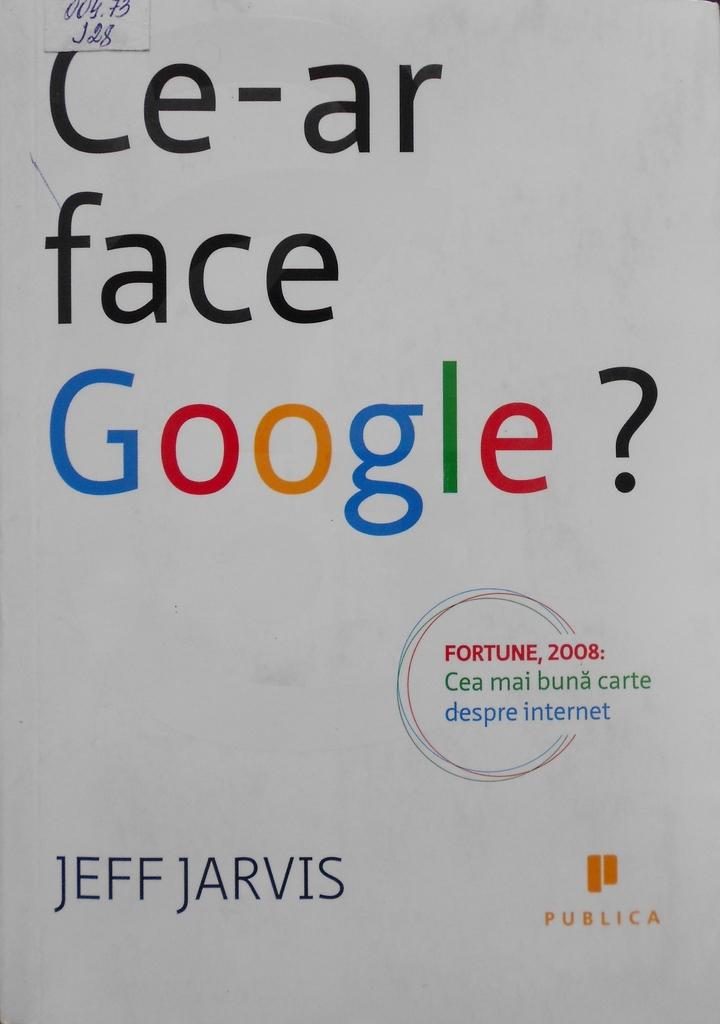Who is the author on this flyer?
Provide a succinct answer. Jeff jarvis. What does this title say?
Your answer should be very brief. Ce-ar face google?. 